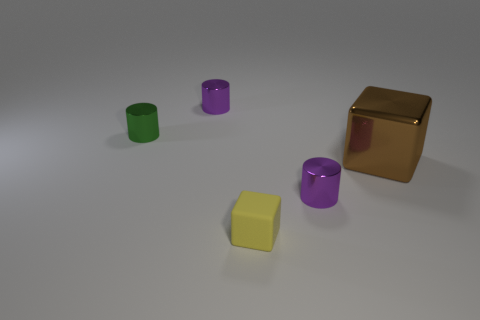There is another small thing that is the same shape as the brown shiny object; what color is it?
Give a very brief answer. Yellow. The brown metallic cube has what size?
Provide a succinct answer. Large. What number of purple metallic cylinders are the same size as the green cylinder?
Provide a short and direct response. 2. Do the tiny purple cylinder behind the big brown block and the tiny purple cylinder in front of the large block have the same material?
Offer a very short reply. Yes. Are there more yellow things than large matte cylinders?
Your answer should be compact. Yes. Is there anything else of the same color as the tiny cube?
Your answer should be very brief. No. Does the small yellow block have the same material as the small green thing?
Make the answer very short. No. Are there fewer big shiny cubes than large brown matte blocks?
Keep it short and to the point. No. Does the tiny yellow matte thing have the same shape as the green object?
Provide a short and direct response. No. What is the color of the tiny rubber thing?
Offer a very short reply. Yellow. 